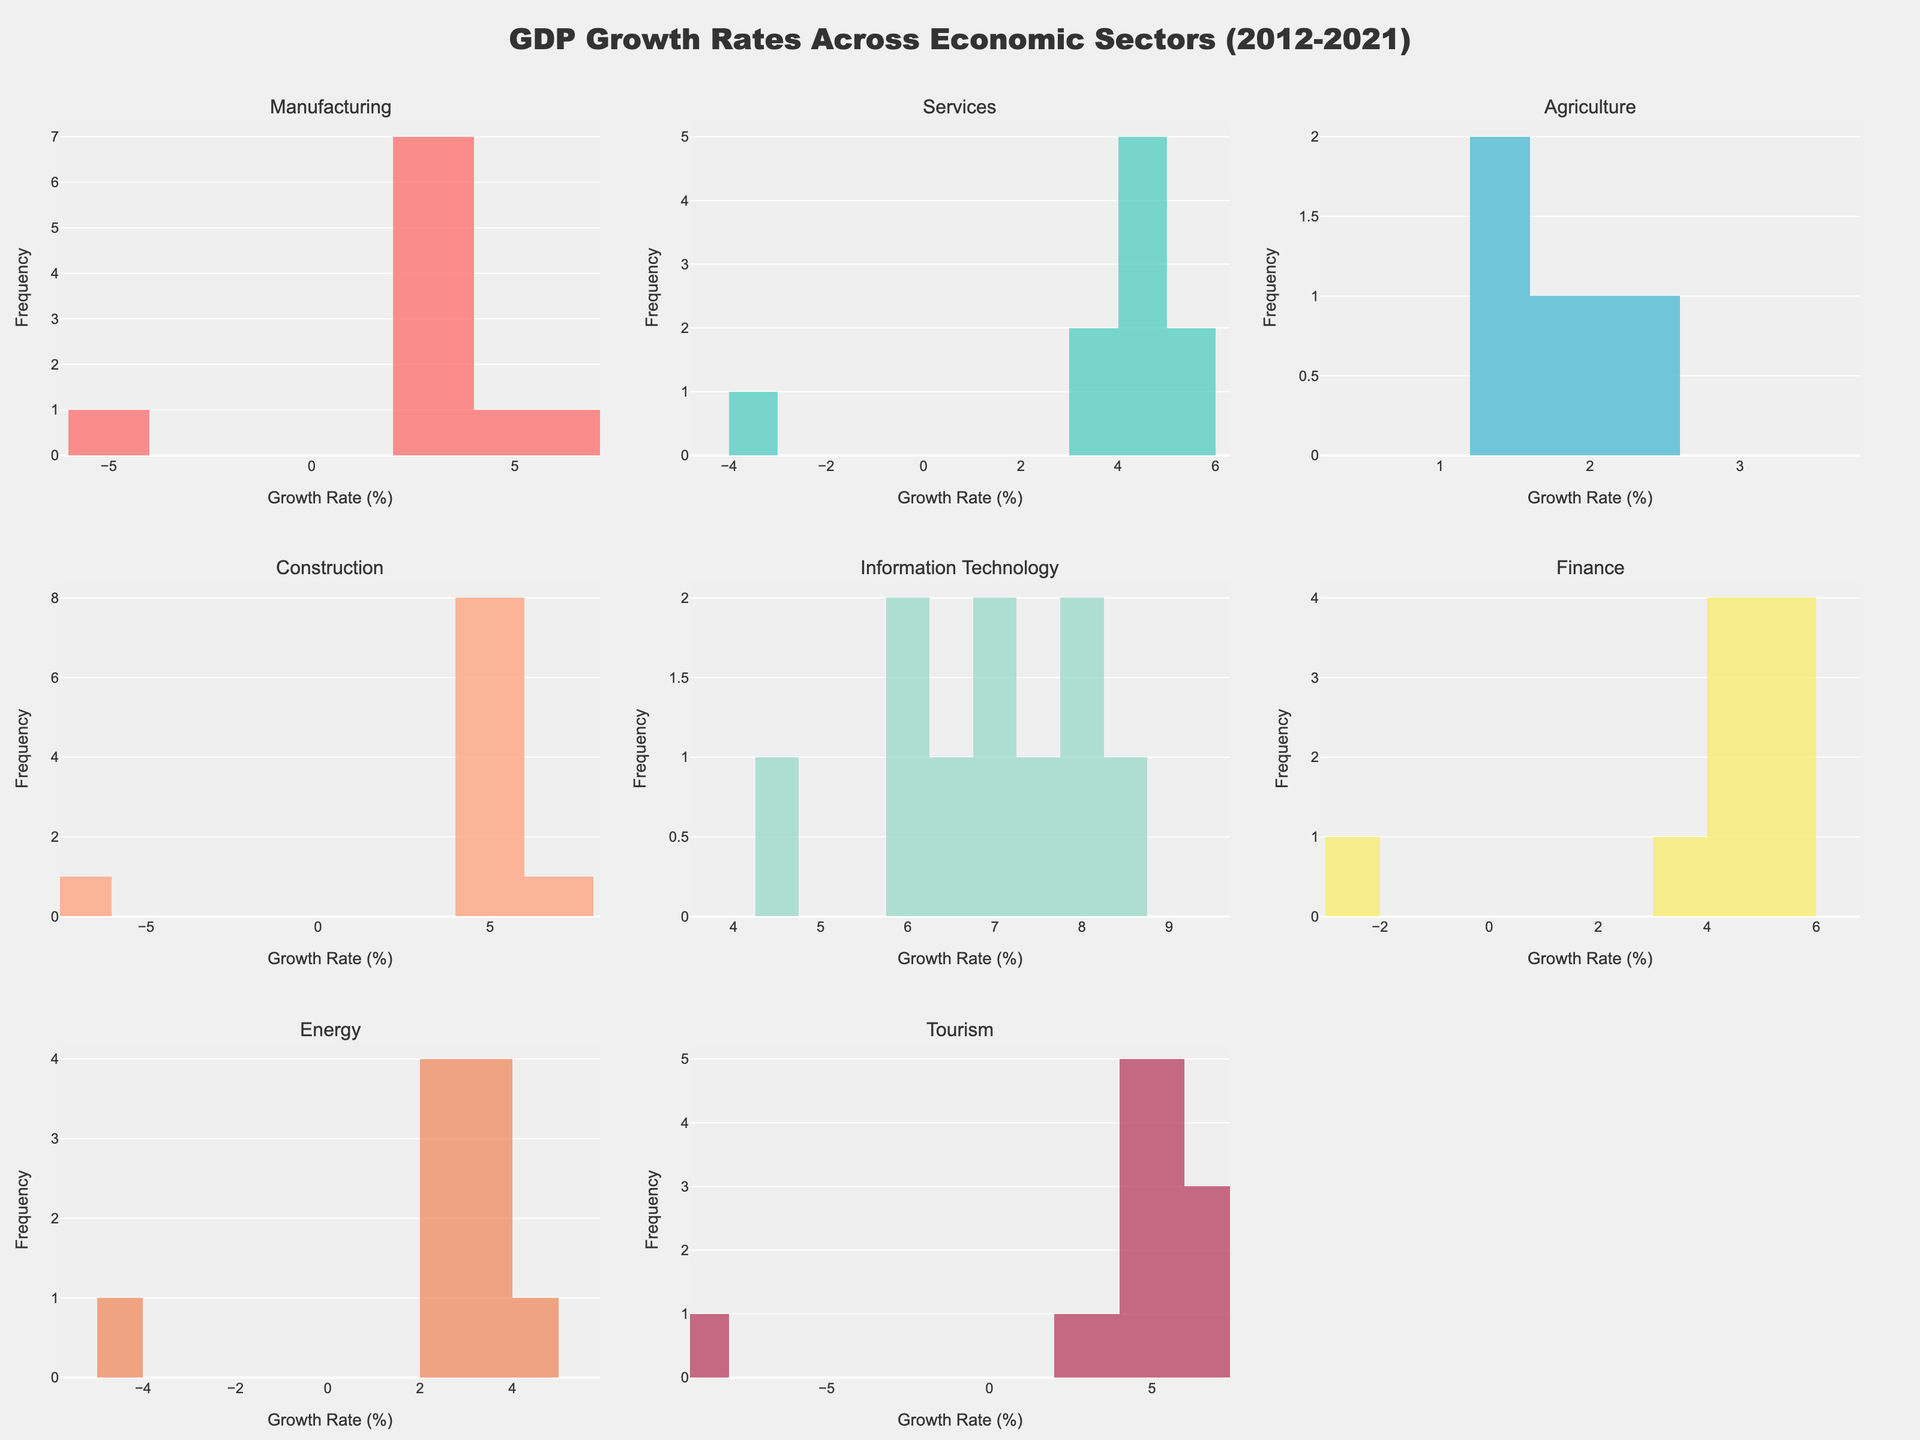Which sector had the highest growth rate in 2021? Look at the histogram for 2021 in each subplot. The Information Technology sector had the highest maximum value for 2021 at 8.7%.
Answer: Information Technology What is the title of the figure? Refer to the top of the figure where the title is displayed.
Answer: GDP Growth Rates Across Economic Sectors (2012-2021) How many sectors had negative growth rates in 2020? Identify the bin containing negative values for the 2020 histogram in each subplot. Count those with negative values.
Answer: 7 Which sector has the widest range of growth rates from 2012 to 2021? Calculate the range by subtracting the minimum value from the maximum value for each sector's histogram. The sector with the largest difference is Construction with a range from -6.5% to 7.2%.
Answer: Construction What is the median growth rate for the Service sector from 2012 to 2021? Arrange the data points for the Services sector and find the middle value of the sorted list. The values for Services are: 3.5, 3.9, 4.1, 4.3, 4.5, 4.7, 5.1, 4.8, -3.8, 5.3. When sorted, the middle values are 4.3 and 4.5, so the median is (4.3+4.5)/2 = 4.4.
Answer: 4.4 Which sector experienced the lowest growth rate and in which year? Identify the lowest value in all histograms, which is -8.2% for Tourism in 2020.
Answer: Tourism, 2020 How does the financial sector compare in growth rate to the manufacturing sector in 2017? Find the histogram bar for 2017 in both sectors. The Financial sector had a growth rate of 5.2%, while Manufacturing had 3.8%. So, Finance was higher.
Answer: The Financial sector had a higher growth rate Which two sectors showed positive growth during every year from 2012 to 2019? Check each sector's histogram for negative values from 2012 to 2019. Information Technology and Services had only positive values during this period.
Answer: Information Technology and Services What is the average growth rate of the Agriculture sector over the entire period? Sum all the values of the Agriculture sector and divide by the total number of years. Values: 1.2, 1.5, 1.8, 1.3, 1.6, 2.1, 2.4, 2.2, 1.5, 2.8. Average = (1.2+1.5+1.8+1.3+1.6+2.1+2.4+2.2+1.5+2.8)/10 = 1.84%.
Answer: 1.84 